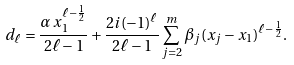<formula> <loc_0><loc_0><loc_500><loc_500>d _ { \ell } = \frac { \alpha \, x _ { 1 } ^ { \ell - \frac { 1 } { 2 } } } { 2 \ell - 1 } + \frac { 2 i ( - 1 ) ^ { \ell } } { 2 \ell - 1 } \sum _ { j = 2 } ^ { m } \beta _ { j } ( x _ { j } - x _ { 1 } ) ^ { \ell - \frac { 1 } { 2 } } .</formula> 